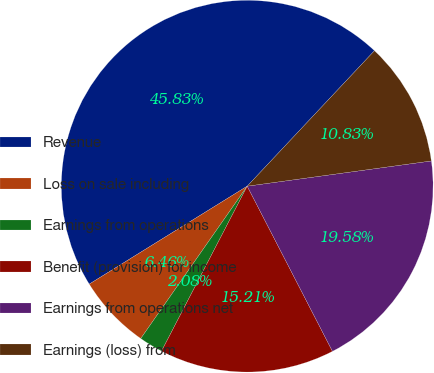Convert chart. <chart><loc_0><loc_0><loc_500><loc_500><pie_chart><fcel>Revenue<fcel>Loss on sale including<fcel>Earnings from operations<fcel>Benefit (provision) for income<fcel>Earnings from operations net<fcel>Earnings (loss) from<nl><fcel>45.83%<fcel>6.46%<fcel>2.08%<fcel>15.21%<fcel>19.58%<fcel>10.83%<nl></chart> 